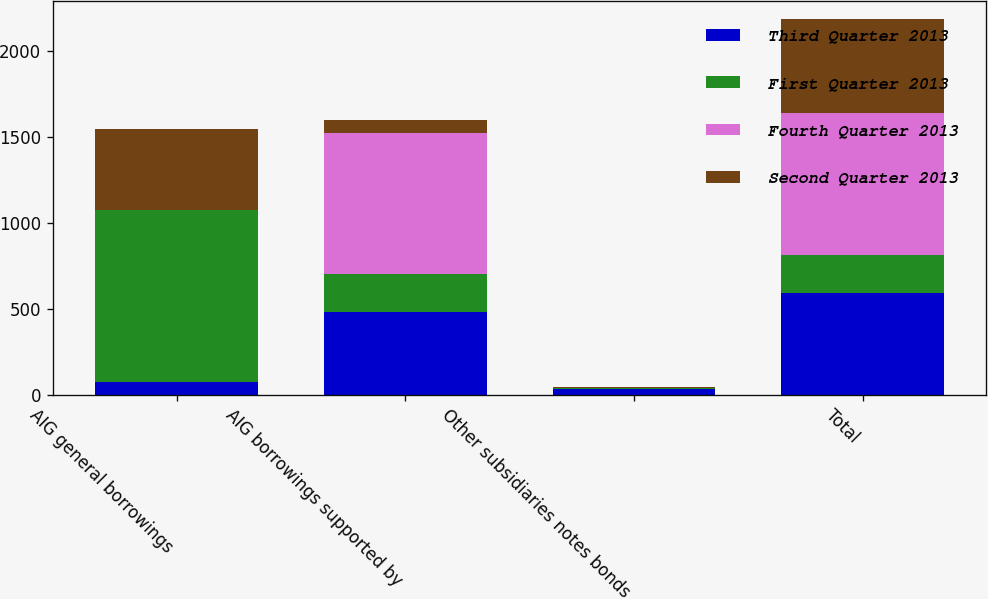<chart> <loc_0><loc_0><loc_500><loc_500><stacked_bar_chart><ecel><fcel>AIG general borrowings<fcel>AIG borrowings supported by<fcel>Other subsidiaries notes bonds<fcel>Total<nl><fcel>Third Quarter 2013<fcel>75<fcel>483<fcel>35<fcel>593<nl><fcel>First Quarter 2013<fcel>1000<fcel>222<fcel>6<fcel>222<nl><fcel>Fourth Quarter 2013<fcel>2<fcel>819<fcel>1<fcel>822<nl><fcel>Second Quarter 2013<fcel>469<fcel>76<fcel>1<fcel>546<nl></chart> 